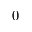<formula> <loc_0><loc_0><loc_500><loc_500>0</formula> 